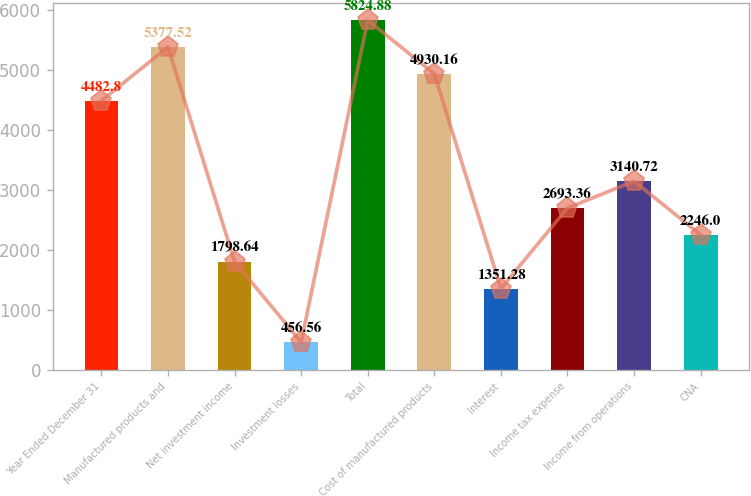Convert chart. <chart><loc_0><loc_0><loc_500><loc_500><bar_chart><fcel>Year Ended December 31<fcel>Manufactured products and<fcel>Net investment income<fcel>Investment losses<fcel>Total<fcel>Cost of manufactured products<fcel>Interest<fcel>Income tax expense<fcel>Income from operations<fcel>CNA<nl><fcel>4482.8<fcel>5377.52<fcel>1798.64<fcel>456.56<fcel>5824.88<fcel>4930.16<fcel>1351.28<fcel>2693.36<fcel>3140.72<fcel>2246<nl></chart> 